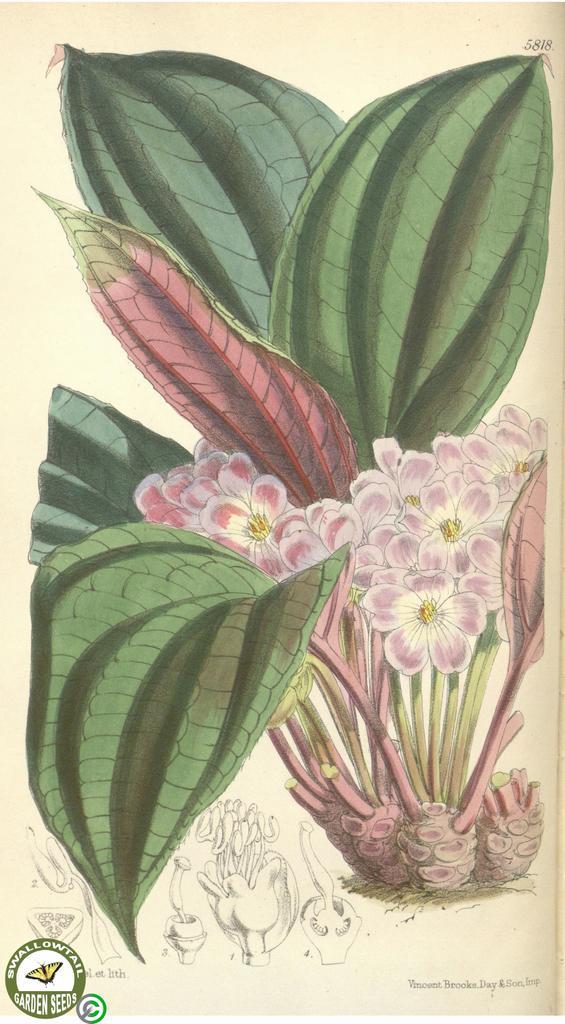Please provide a concise description of this image. There is a painting picture of a flower plant as we can see in the middle of this image. There is a watermark in the bottom left corner of this image. 